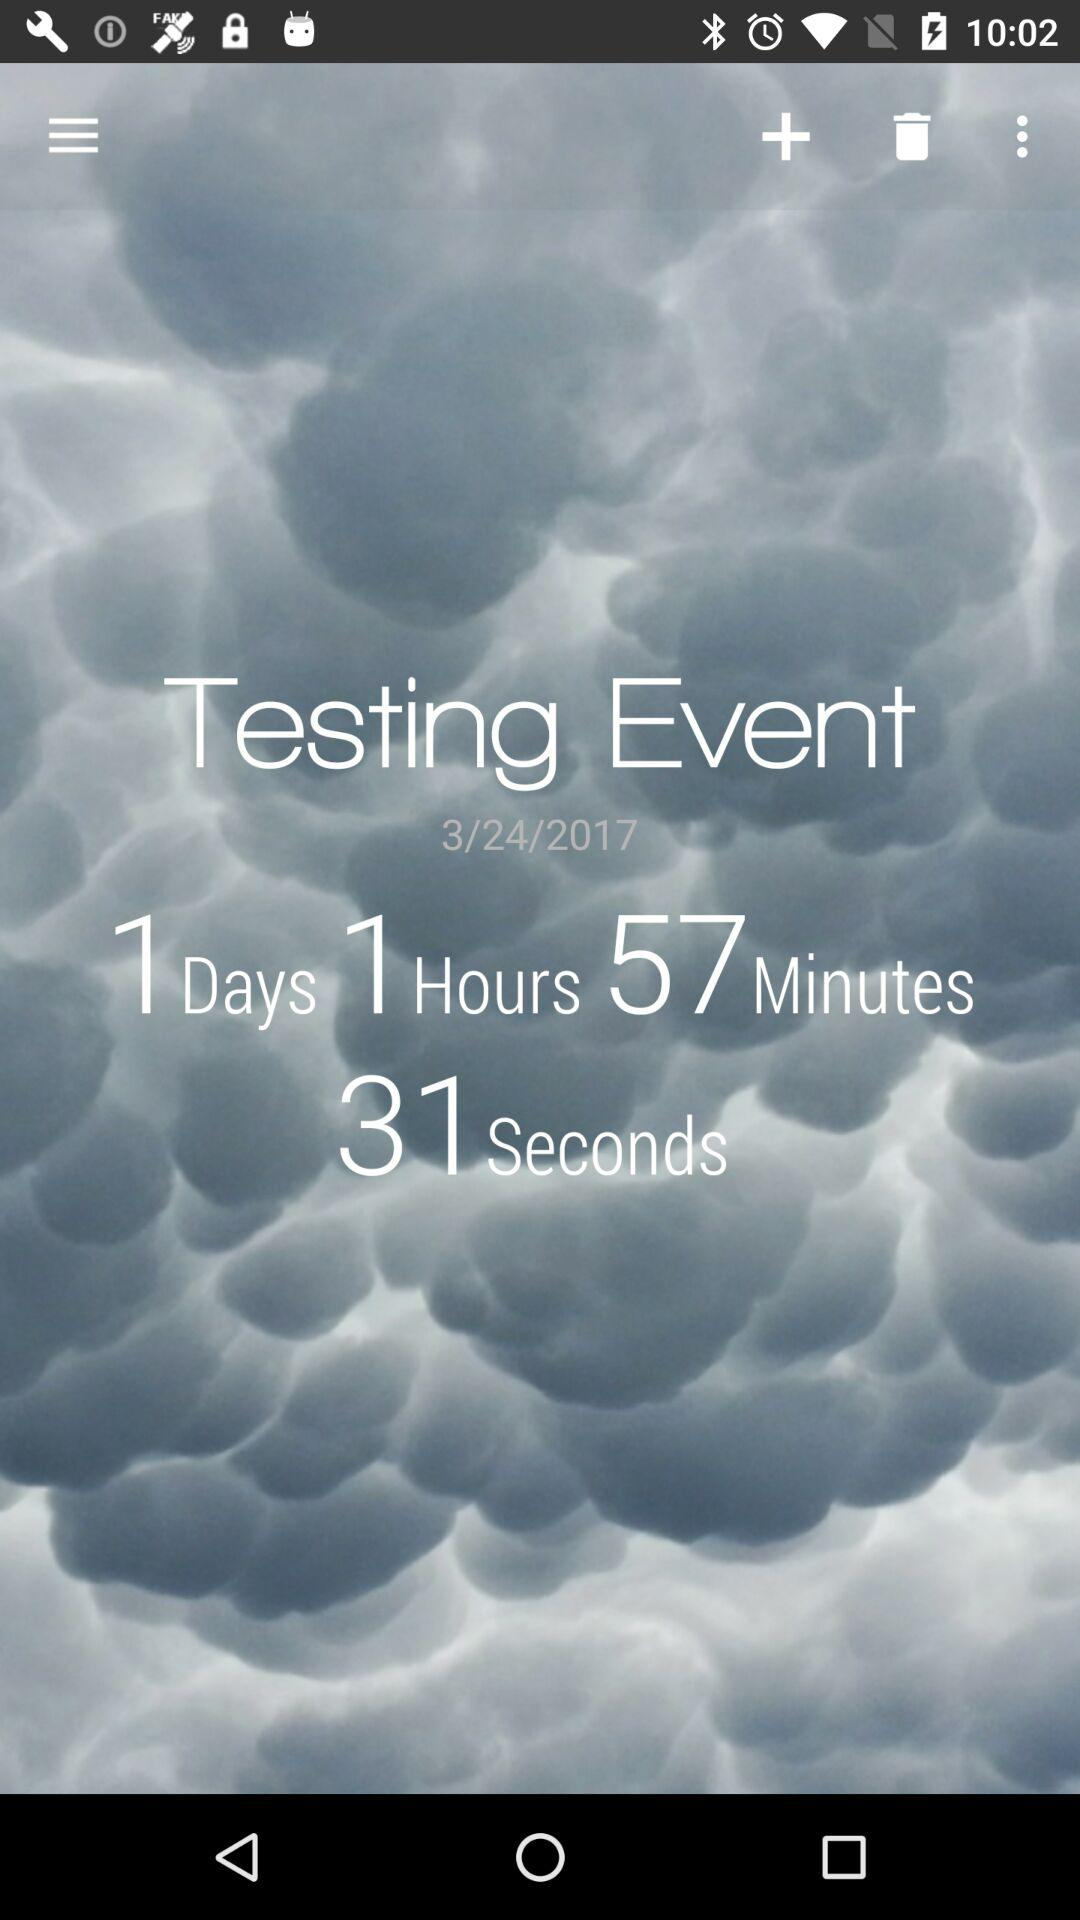How many days are left until the event?
Answer the question using a single word or phrase. 1 